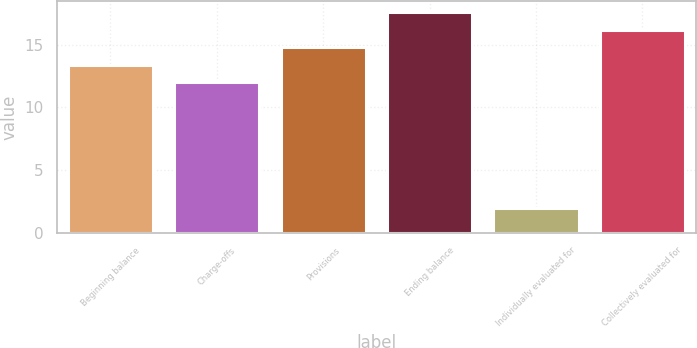Convert chart to OTSL. <chart><loc_0><loc_0><loc_500><loc_500><bar_chart><fcel>Beginning balance<fcel>Charge-offs<fcel>Provisions<fcel>Ending balance<fcel>Individually evaluated for<fcel>Collectively evaluated for<nl><fcel>13.4<fcel>12<fcel>14.8<fcel>17.6<fcel>2<fcel>16.2<nl></chart> 